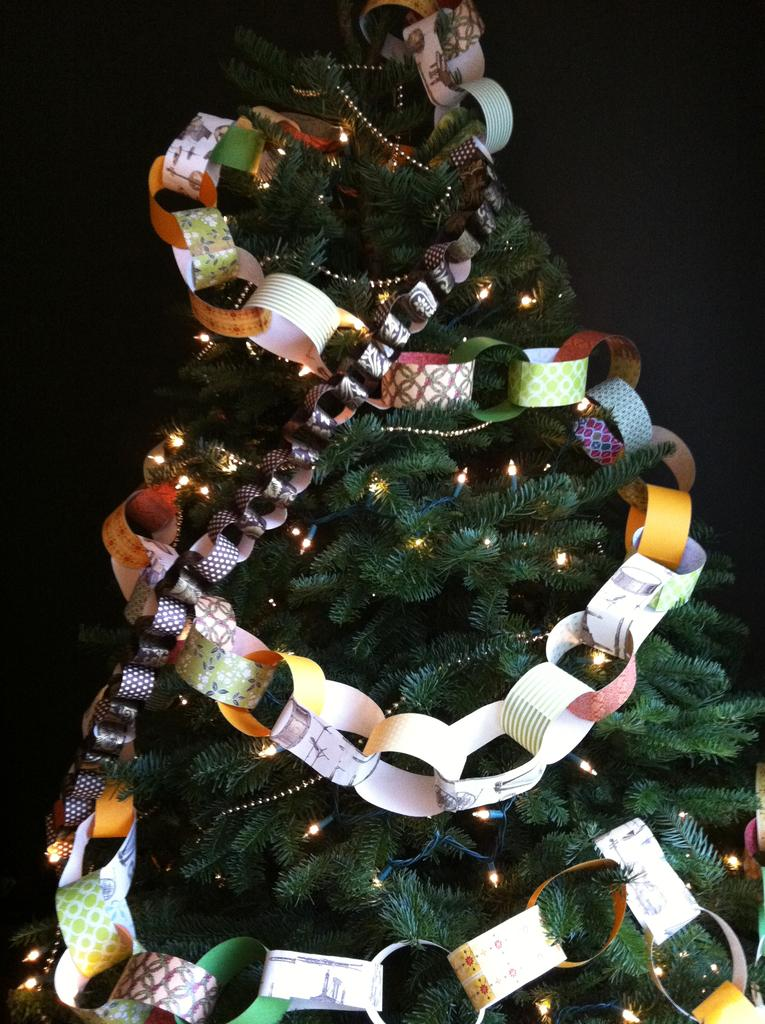What is the main subject in the center of the image? There is a tree in the center of the image. What else can be seen in the image besides the tree? There are lights and decorations in the image. What color is the background of the image? The background of the image is black. What type of grain is being harvested in the image? There is no grain or harvesting activity present in the image; it features a tree with lights and decorations against a black background. What kind of roof can be seen on the building in the image? There is no building or roof visible in the image; it only shows a tree, lights, decorations, and a black background. 